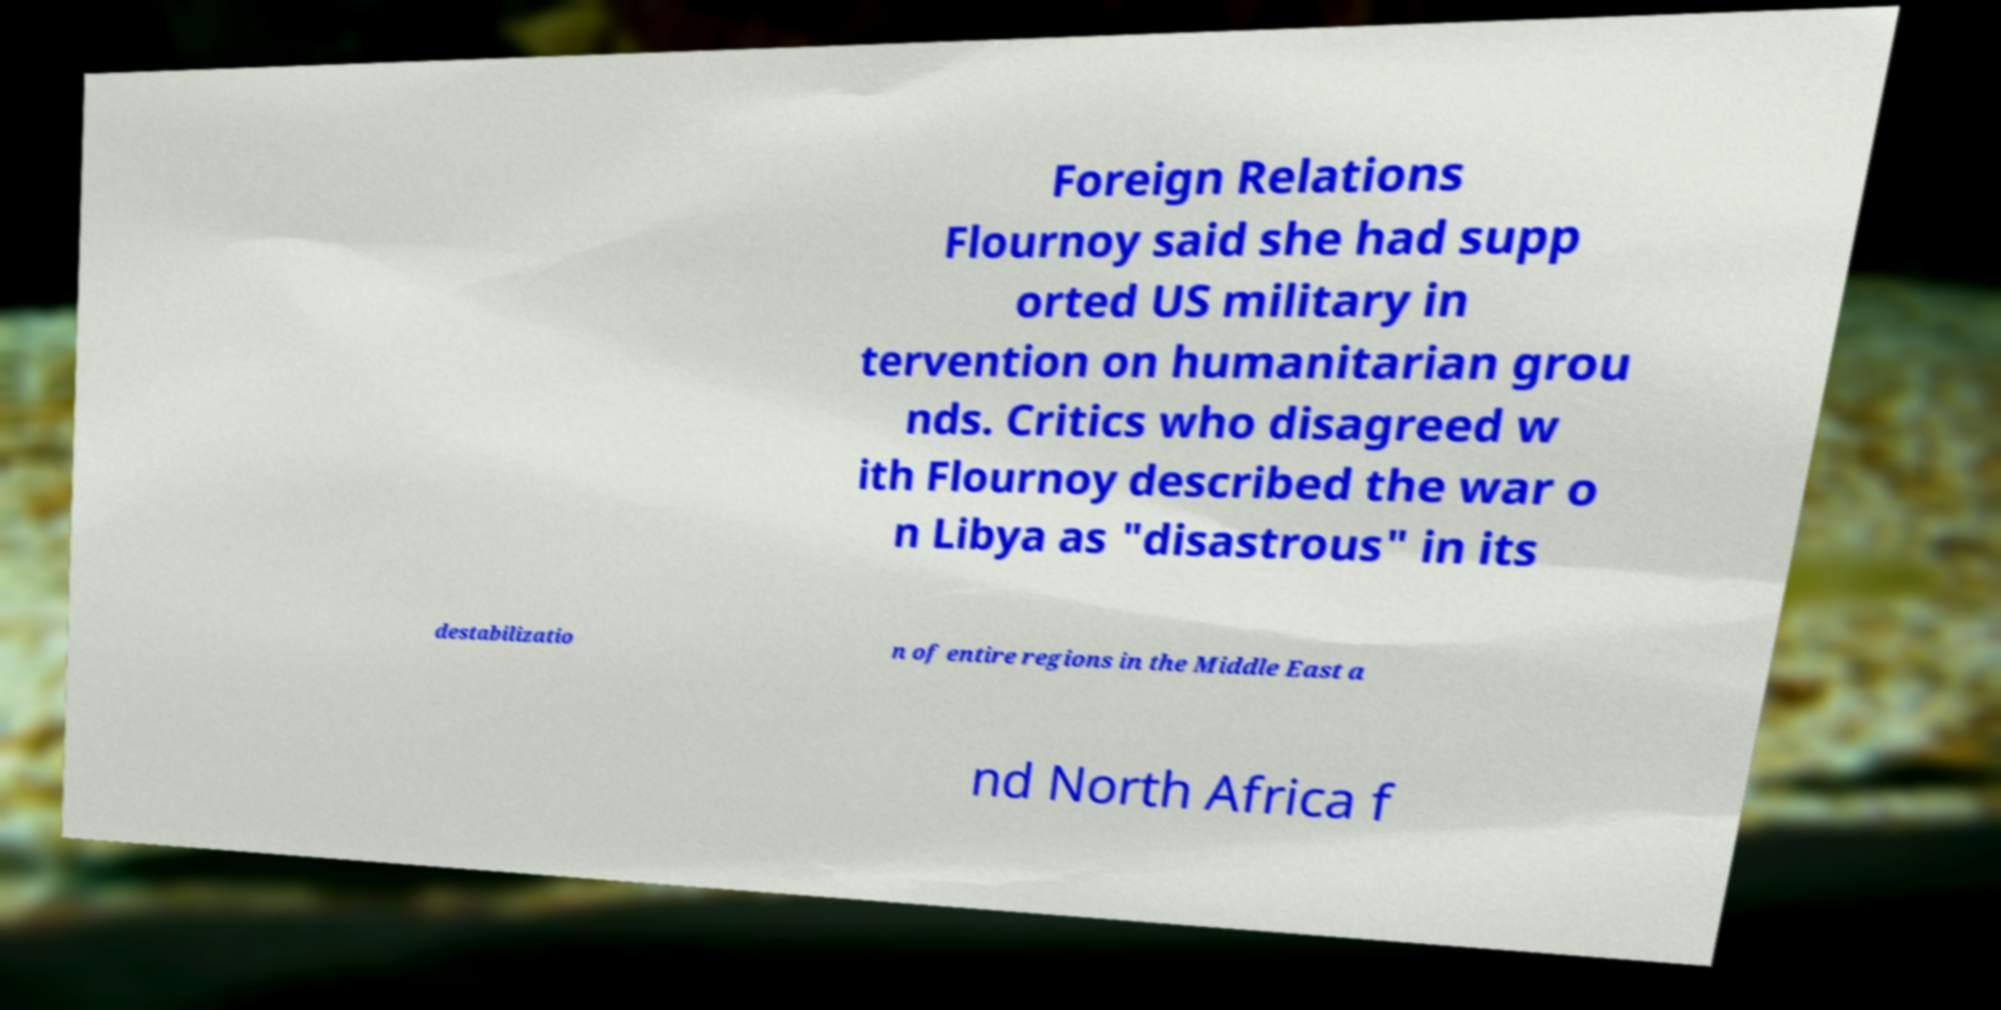I need the written content from this picture converted into text. Can you do that? Foreign Relations Flournoy said she had supp orted US military in tervention on humanitarian grou nds. Critics who disagreed w ith Flournoy described the war o n Libya as "disastrous" in its destabilizatio n of entire regions in the Middle East a nd North Africa f 